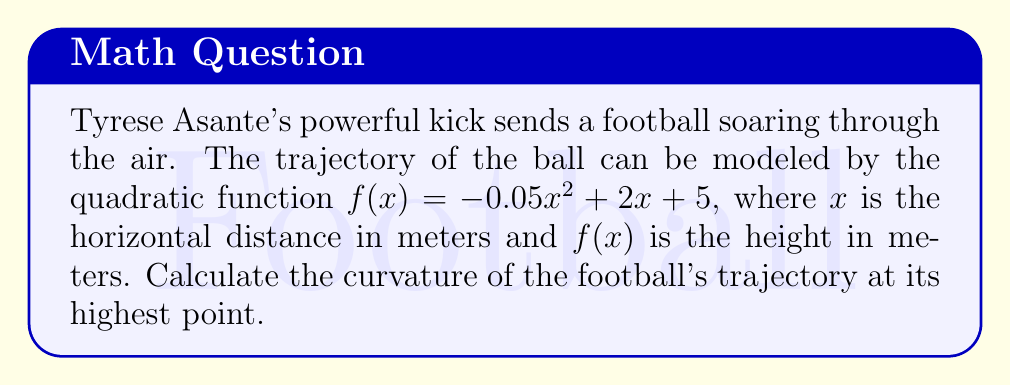Teach me how to tackle this problem. To find the curvature of the football's trajectory, we'll follow these steps:

1) The curvature $\kappa$ of a function $y = f(x)$ at any point is given by:

   $$\kappa = \frac{|f''(x)|}{(1 + (f'(x))^2)^{3/2}}$$

2) First, we need to find $f'(x)$ and $f''(x)$:
   
   $f'(x) = -0.1x + 2$
   $f''(x) = -0.1$

3) The highest point of the trajectory occurs when $f'(x) = 0$:

   $-0.1x + 2 = 0$
   $x = 20$ meters

4) At the highest point $(20, f(20))$:

   $f'(20) = -0.1(20) + 2 = 0$
   $f''(20) = -0.1$

5) Now we can substitute these values into the curvature formula:

   $$\kappa = \frac{|-0.1|}{(1 + (0)^2)^{3/2}} = \frac{0.1}{1} = 0.1$$

Therefore, the curvature of the football's trajectory at its highest point is 0.1 m^(-1).
Answer: $0.1$ m^(-1) 